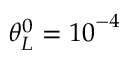<formula> <loc_0><loc_0><loc_500><loc_500>\theta _ { L } ^ { 0 } = { { 1 0 } ^ { - 4 } }</formula> 